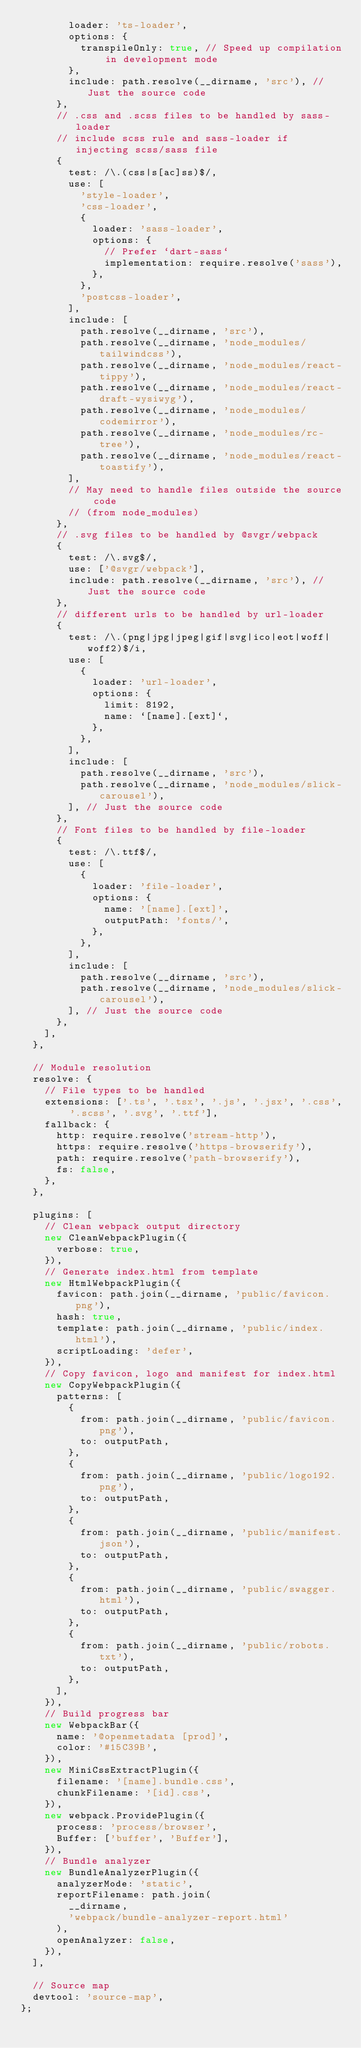Convert code to text. <code><loc_0><loc_0><loc_500><loc_500><_JavaScript_>        loader: 'ts-loader',
        options: {
          transpileOnly: true, // Speed up compilation in development mode
        },
        include: path.resolve(__dirname, 'src'), // Just the source code
      },
      // .css and .scss files to be handled by sass-loader
      // include scss rule and sass-loader if injecting scss/sass file
      {
        test: /\.(css|s[ac]ss)$/,
        use: [
          'style-loader',
          'css-loader',
          {
            loader: 'sass-loader',
            options: {
              // Prefer `dart-sass`
              implementation: require.resolve('sass'),
            },
          },
          'postcss-loader',
        ],
        include: [
          path.resolve(__dirname, 'src'),
          path.resolve(__dirname, 'node_modules/tailwindcss'),
          path.resolve(__dirname, 'node_modules/react-tippy'),
          path.resolve(__dirname, 'node_modules/react-draft-wysiwyg'),
          path.resolve(__dirname, 'node_modules/codemirror'),
          path.resolve(__dirname, 'node_modules/rc-tree'),
          path.resolve(__dirname, 'node_modules/react-toastify'),
        ],
        // May need to handle files outside the source code
        // (from node_modules)
      },
      // .svg files to be handled by @svgr/webpack
      {
        test: /\.svg$/,
        use: ['@svgr/webpack'],
        include: path.resolve(__dirname, 'src'), // Just the source code
      },
      // different urls to be handled by url-loader
      {
        test: /\.(png|jpg|jpeg|gif|svg|ico|eot|woff|woff2)$/i,
        use: [
          {
            loader: 'url-loader',
            options: {
              limit: 8192,
              name: `[name].[ext]`,
            },
          },
        ],
        include: [
          path.resolve(__dirname, 'src'),
          path.resolve(__dirname, 'node_modules/slick-carousel'),
        ], // Just the source code
      },
      // Font files to be handled by file-loader
      {
        test: /\.ttf$/,
        use: [
          {
            loader: 'file-loader',
            options: {
              name: '[name].[ext]',
              outputPath: 'fonts/',
            },
          },
        ],
        include: [
          path.resolve(__dirname, 'src'),
          path.resolve(__dirname, 'node_modules/slick-carousel'),
        ], // Just the source code
      },
    ],
  },

  // Module resolution
  resolve: {
    // File types to be handled
    extensions: ['.ts', '.tsx', '.js', '.jsx', '.css', '.scss', '.svg', '.ttf'],
    fallback: {
      http: require.resolve('stream-http'),
      https: require.resolve('https-browserify'),
      path: require.resolve('path-browserify'),
      fs: false,
    },
  },

  plugins: [
    // Clean webpack output directory
    new CleanWebpackPlugin({
      verbose: true,
    }),
    // Generate index.html from template
    new HtmlWebpackPlugin({
      favicon: path.join(__dirname, 'public/favicon.png'),
      hash: true,
      template: path.join(__dirname, 'public/index.html'),
      scriptLoading: 'defer',
    }),
    // Copy favicon, logo and manifest for index.html
    new CopyWebpackPlugin({
      patterns: [
        {
          from: path.join(__dirname, 'public/favicon.png'),
          to: outputPath,
        },
        {
          from: path.join(__dirname, 'public/logo192.png'),
          to: outputPath,
        },
        {
          from: path.join(__dirname, 'public/manifest.json'),
          to: outputPath,
        },
        {
          from: path.join(__dirname, 'public/swagger.html'),
          to: outputPath,
        },
        {
          from: path.join(__dirname, 'public/robots.txt'),
          to: outputPath,
        },
      ],
    }),
    // Build progress bar
    new WebpackBar({
      name: '@openmetadata [prod]',
      color: '#15C39B',
    }),
    new MiniCssExtractPlugin({
      filename: '[name].bundle.css',
      chunkFilename: '[id].css',
    }),
    new webpack.ProvidePlugin({
      process: 'process/browser',
      Buffer: ['buffer', 'Buffer'],
    }),
    // Bundle analyzer
    new BundleAnalyzerPlugin({
      analyzerMode: 'static',
      reportFilename: path.join(
        __dirname,
        'webpack/bundle-analyzer-report.html'
      ),
      openAnalyzer: false,
    }),
  ],

  // Source map
  devtool: 'source-map',
};
</code> 